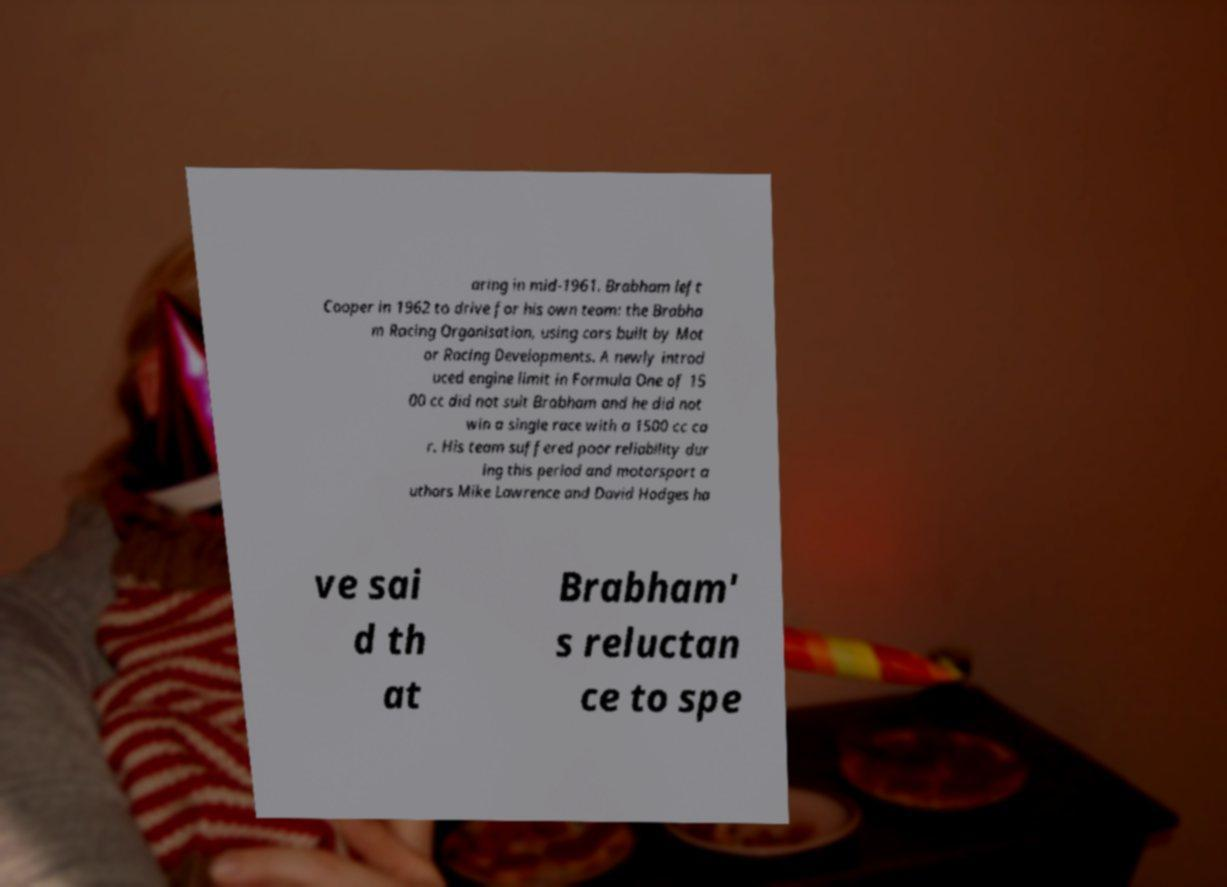Can you accurately transcribe the text from the provided image for me? aring in mid-1961. Brabham left Cooper in 1962 to drive for his own team: the Brabha m Racing Organisation, using cars built by Mot or Racing Developments. A newly introd uced engine limit in Formula One of 15 00 cc did not suit Brabham and he did not win a single race with a 1500 cc ca r. His team suffered poor reliability dur ing this period and motorsport a uthors Mike Lawrence and David Hodges ha ve sai d th at Brabham' s reluctan ce to spe 